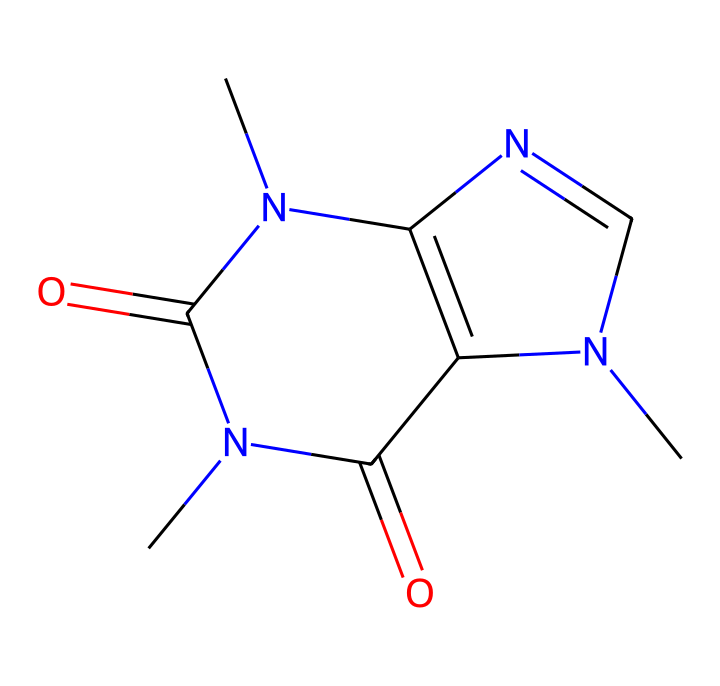What is the molecular formula of caffeine? To find the molecular formula, we identify the types and counts of each atom in the SMILES representation. The SMILES states there are 8 carbon atoms (C), 10 hydrogen atoms (H), 4 nitrogen atoms (N), and 2 oxygen atoms (O). Therefore, the molecular formula is C8H10N4O2.
Answer: C8H10N4O2 How many rings are in the structure of caffeine? The structure of caffeine indicates the presence of two distinct rings, identified by the fused cyclic systems in the SMILES representation.
Answer: 2 What type of geometric isomerism is observed in caffeine? Caffeine exhibits cis-trans isomerism, as the structure allows for different spatial arrangements of atoms around the double bonds present in the rings, leading to distinct geometric forms.
Answer: cis-trans What are the functional groups present in caffeine? Analyzing caffeine shows it possesses amine and carbonyl functional groups, seen from the nitrogen atoms and the carbon-nitrogen double bonds in its structure.
Answer: amine and carbonyl How does caffeine's structure influence its activity? Caffeine's planar structure and nitrogen-containing rings allow for efficient interaction with adenosine receptors in the brain, impacting its stimulant effects.
Answer: stimulant properties What is the effect of geometric isomers on caffeine's properties? The geometric isomers of caffeine may have differing biological activities and affinities for receptors, which could lead to variations in stimulant effects among the isomers.
Answer: differing biological activities 